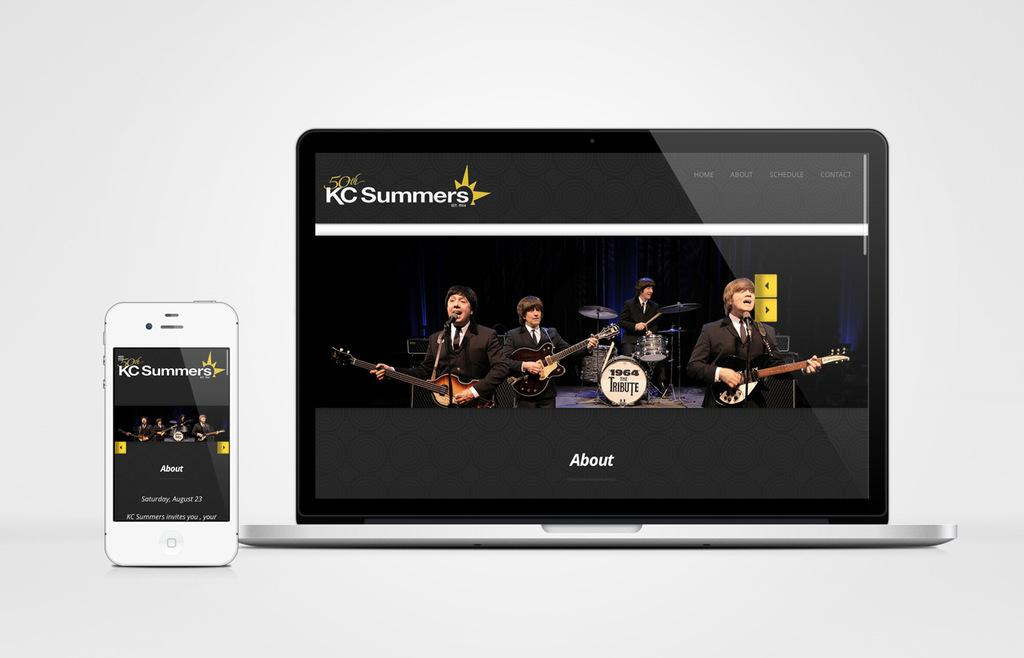Provide a one-sentence caption for the provided image. A smart phone and tablet are displaying the KC Summers website. 